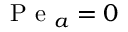Convert formula to latex. <formula><loc_0><loc_0><loc_500><loc_500>P e _ { a } = 0</formula> 